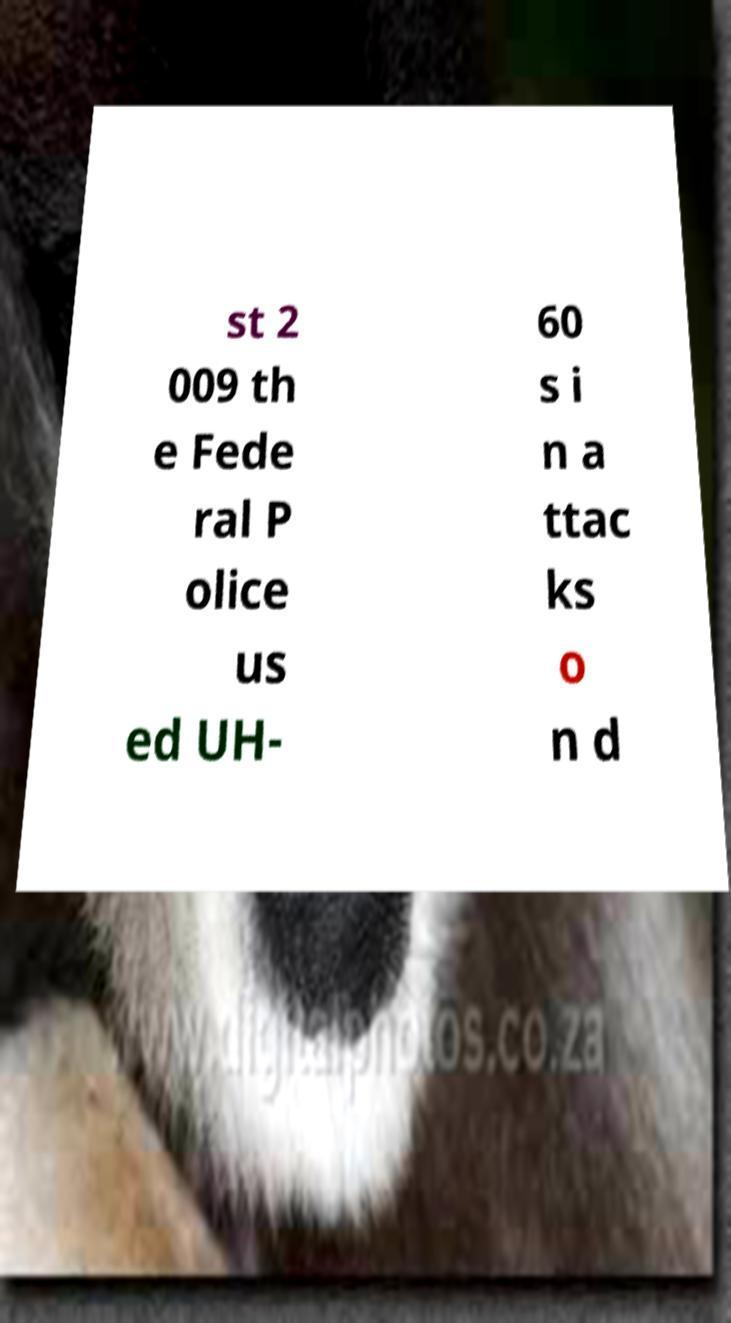Could you assist in decoding the text presented in this image and type it out clearly? st 2 009 th e Fede ral P olice us ed UH- 60 s i n a ttac ks o n d 